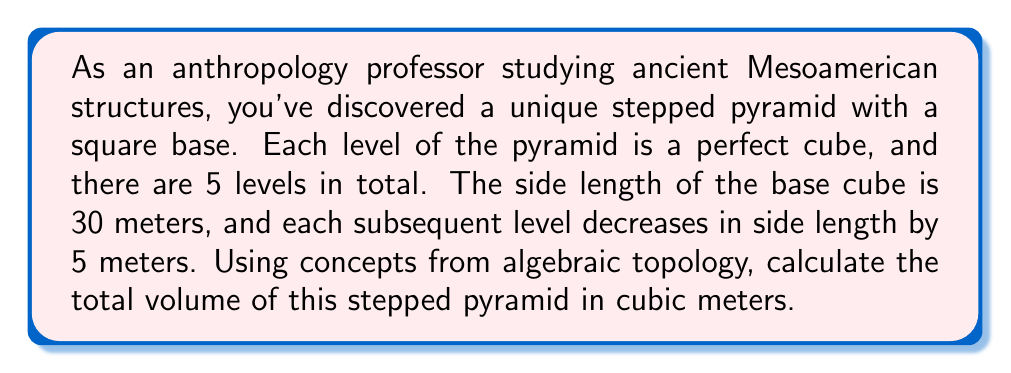Provide a solution to this math problem. Let's approach this step-by-step using algebraic topology concepts:

1) First, we need to identify the side lengths of each cube:
   Level 1 (base): 30 m
   Level 2: 25 m
   Level 3: 20 m
   Level 4: 15 m
   Level 5 (top): 10 m

2) Now, we can represent each cube as a 3-simplex in algebraic topology. The volume of each 3-simplex (cube) is given by the cube of its side length.

3) Let's calculate the volume of each level:
   $$V_1 = 30^3 = 27,000 \text{ m}^3$$
   $$V_2 = 25^3 = 15,625 \text{ m}^3$$
   $$V_3 = 20^3 = 8,000 \text{ m}^3$$
   $$V_4 = 15^3 = 3,375 \text{ m}^3$$
   $$V_5 = 10^3 = 1,000 \text{ m}^3$$

4) In algebraic topology, we can consider the pyramid as a chain complex of 3-simplices. The total volume is the sum of all these 3-simplices:

   $$V_{total} = \sum_{i=1}^5 V_i$$

5) Substituting the values:
   $$V_{total} = 27,000 + 15,625 + 8,000 + 3,375 + 1,000$$

6) Computing the sum:
   $$V_{total} = 55,000 \text{ m}^3$$

Thus, the total volume of the stepped pyramid is 55,000 cubic meters.
Answer: 55,000 m³ 